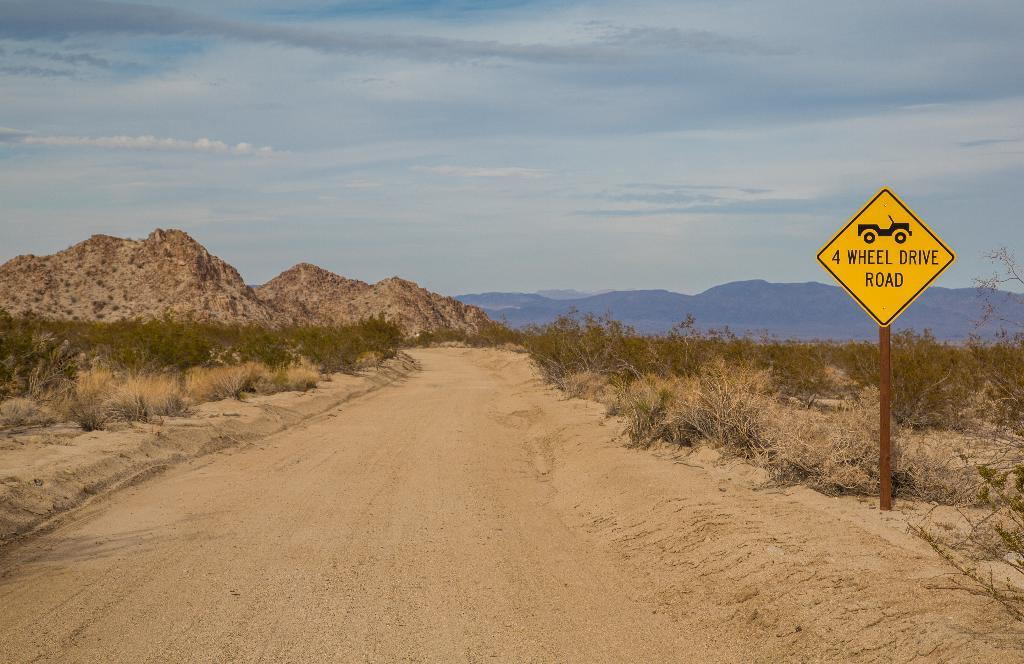<image>
Write a terse but informative summary of the picture. A sign on the side of a desert road says 4 Wheel Drive Road. 